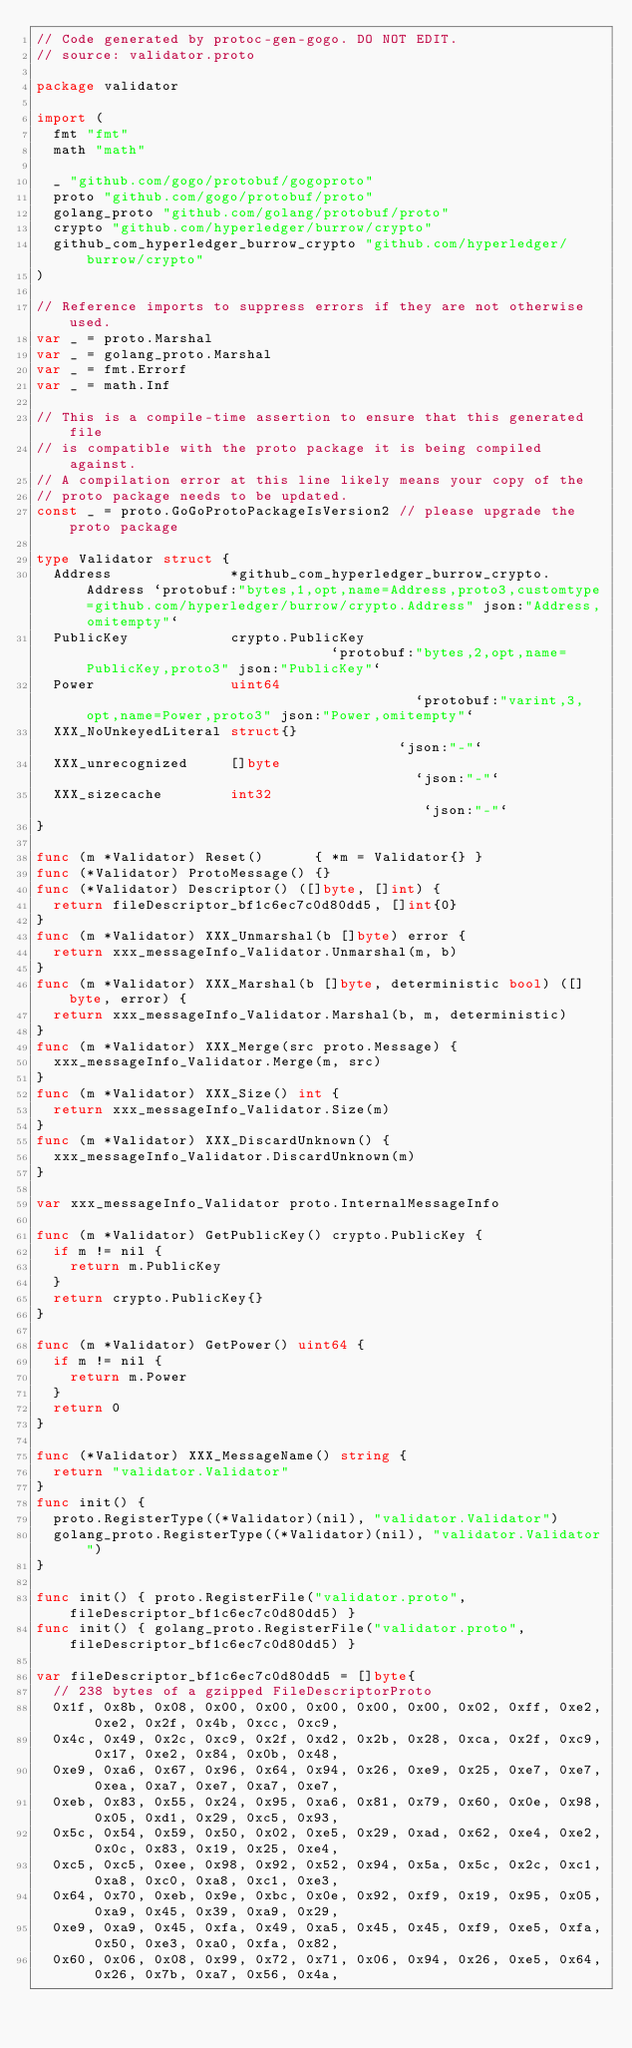Convert code to text. <code><loc_0><loc_0><loc_500><loc_500><_Go_>// Code generated by protoc-gen-gogo. DO NOT EDIT.
// source: validator.proto

package validator

import (
	fmt "fmt"
	math "math"

	_ "github.com/gogo/protobuf/gogoproto"
	proto "github.com/gogo/protobuf/proto"
	golang_proto "github.com/golang/protobuf/proto"
	crypto "github.com/hyperledger/burrow/crypto"
	github_com_hyperledger_burrow_crypto "github.com/hyperledger/burrow/crypto"
)

// Reference imports to suppress errors if they are not otherwise used.
var _ = proto.Marshal
var _ = golang_proto.Marshal
var _ = fmt.Errorf
var _ = math.Inf

// This is a compile-time assertion to ensure that this generated file
// is compatible with the proto package it is being compiled against.
// A compilation error at this line likely means your copy of the
// proto package needs to be updated.
const _ = proto.GoGoProtoPackageIsVersion2 // please upgrade the proto package

type Validator struct {
	Address              *github_com_hyperledger_burrow_crypto.Address `protobuf:"bytes,1,opt,name=Address,proto3,customtype=github.com/hyperledger/burrow/crypto.Address" json:"Address,omitempty"`
	PublicKey            crypto.PublicKey                              `protobuf:"bytes,2,opt,name=PublicKey,proto3" json:"PublicKey"`
	Power                uint64                                        `protobuf:"varint,3,opt,name=Power,proto3" json:"Power,omitempty"`
	XXX_NoUnkeyedLiteral struct{}                                      `json:"-"`
	XXX_unrecognized     []byte                                        `json:"-"`
	XXX_sizecache        int32                                         `json:"-"`
}

func (m *Validator) Reset()      { *m = Validator{} }
func (*Validator) ProtoMessage() {}
func (*Validator) Descriptor() ([]byte, []int) {
	return fileDescriptor_bf1c6ec7c0d80dd5, []int{0}
}
func (m *Validator) XXX_Unmarshal(b []byte) error {
	return xxx_messageInfo_Validator.Unmarshal(m, b)
}
func (m *Validator) XXX_Marshal(b []byte, deterministic bool) ([]byte, error) {
	return xxx_messageInfo_Validator.Marshal(b, m, deterministic)
}
func (m *Validator) XXX_Merge(src proto.Message) {
	xxx_messageInfo_Validator.Merge(m, src)
}
func (m *Validator) XXX_Size() int {
	return xxx_messageInfo_Validator.Size(m)
}
func (m *Validator) XXX_DiscardUnknown() {
	xxx_messageInfo_Validator.DiscardUnknown(m)
}

var xxx_messageInfo_Validator proto.InternalMessageInfo

func (m *Validator) GetPublicKey() crypto.PublicKey {
	if m != nil {
		return m.PublicKey
	}
	return crypto.PublicKey{}
}

func (m *Validator) GetPower() uint64 {
	if m != nil {
		return m.Power
	}
	return 0
}

func (*Validator) XXX_MessageName() string {
	return "validator.Validator"
}
func init() {
	proto.RegisterType((*Validator)(nil), "validator.Validator")
	golang_proto.RegisterType((*Validator)(nil), "validator.Validator")
}

func init() { proto.RegisterFile("validator.proto", fileDescriptor_bf1c6ec7c0d80dd5) }
func init() { golang_proto.RegisterFile("validator.proto", fileDescriptor_bf1c6ec7c0d80dd5) }

var fileDescriptor_bf1c6ec7c0d80dd5 = []byte{
	// 238 bytes of a gzipped FileDescriptorProto
	0x1f, 0x8b, 0x08, 0x00, 0x00, 0x00, 0x00, 0x00, 0x02, 0xff, 0xe2, 0xe2, 0x2f, 0x4b, 0xcc, 0xc9,
	0x4c, 0x49, 0x2c, 0xc9, 0x2f, 0xd2, 0x2b, 0x28, 0xca, 0x2f, 0xc9, 0x17, 0xe2, 0x84, 0x0b, 0x48,
	0xe9, 0xa6, 0x67, 0x96, 0x64, 0x94, 0x26, 0xe9, 0x25, 0xe7, 0xe7, 0xea, 0xa7, 0xe7, 0xa7, 0xe7,
	0xeb, 0x83, 0x55, 0x24, 0x95, 0xa6, 0x81, 0x79, 0x60, 0x0e, 0x98, 0x05, 0xd1, 0x29, 0xc5, 0x93,
	0x5c, 0x54, 0x59, 0x50, 0x02, 0xe5, 0x29, 0xad, 0x62, 0xe4, 0xe2, 0x0c, 0x83, 0x19, 0x25, 0xe4,
	0xc5, 0xc5, 0xee, 0x98, 0x92, 0x52, 0x94, 0x5a, 0x5c, 0x2c, 0xc1, 0xa8, 0xc0, 0xa8, 0xc1, 0xe3,
	0x64, 0x70, 0xeb, 0x9e, 0xbc, 0x0e, 0x92, 0xf9, 0x19, 0x95, 0x05, 0xa9, 0x45, 0x39, 0xa9, 0x29,
	0xe9, 0xa9, 0x45, 0xfa, 0x49, 0xa5, 0x45, 0x45, 0xf9, 0xe5, 0xfa, 0x50, 0xe3, 0xa0, 0xfa, 0x82,
	0x60, 0x06, 0x08, 0x99, 0x72, 0x71, 0x06, 0x94, 0x26, 0xe5, 0x64, 0x26, 0x7b, 0xa7, 0x56, 0x4a,</code> 